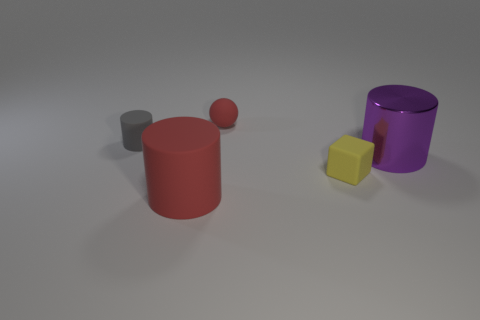There is a yellow rubber thing that is the same size as the gray cylinder; what shape is it?
Ensure brevity in your answer.  Cube. What number of red things are tiny things or large objects?
Give a very brief answer. 2. What number of rubber cubes are the same color as the shiny cylinder?
Provide a short and direct response. 0. Is the material of the tiny yellow thing the same as the purple object?
Keep it short and to the point. No. There is a rubber cylinder that is in front of the small yellow object; how many tiny blocks are left of it?
Your response must be concise. 0. Do the red sphere and the purple shiny thing have the same size?
Your response must be concise. No. What number of small gray things are the same material as the tiny gray cylinder?
Provide a succinct answer. 0. The red rubber object that is the same shape as the gray object is what size?
Offer a very short reply. Large. Is the shape of the big thing behind the tiny yellow matte block the same as  the gray rubber thing?
Your answer should be compact. Yes. There is a red rubber object behind the red thing in front of the large purple cylinder; what is its shape?
Keep it short and to the point. Sphere. 